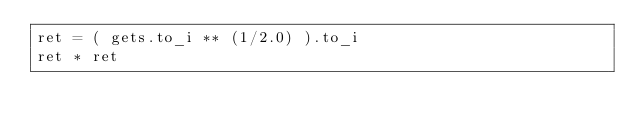<code> <loc_0><loc_0><loc_500><loc_500><_Ruby_>ret = ( gets.to_i ** (1/2.0) ).to_i
ret * ret</code> 